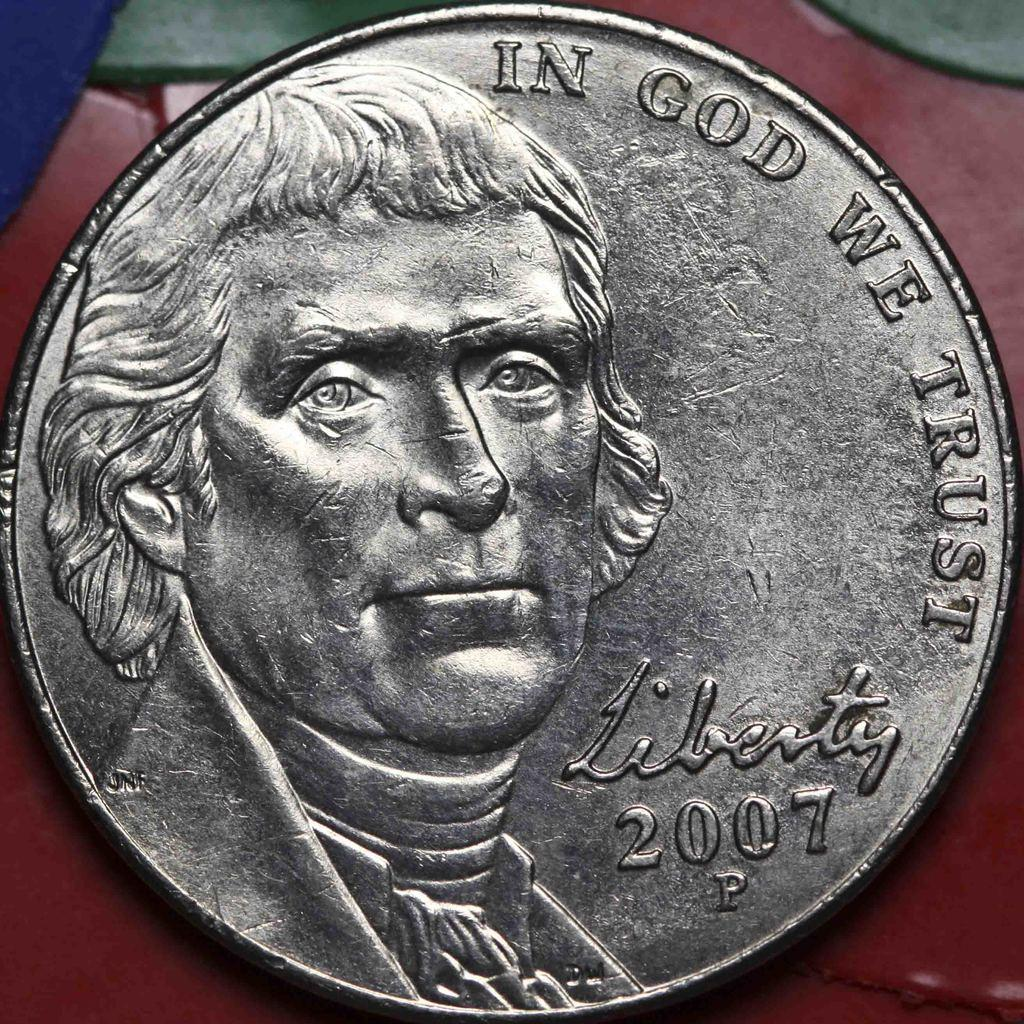What object is depicted in the image? There is a silver coin in the image. What is featured on the surface of the coin? There is a person's face on the coin. Are there any words or symbols on the coin? Yes, there is writing on the coin. Can you tell me how many bees are buzzing around the coin in the image? There are no bees present in the image; it only features a silver coin with a person's face and writing. What type of cork is used to seal the coin in the image? There is no cork present in the image; it only features a silver coin with a person's face and writing. 